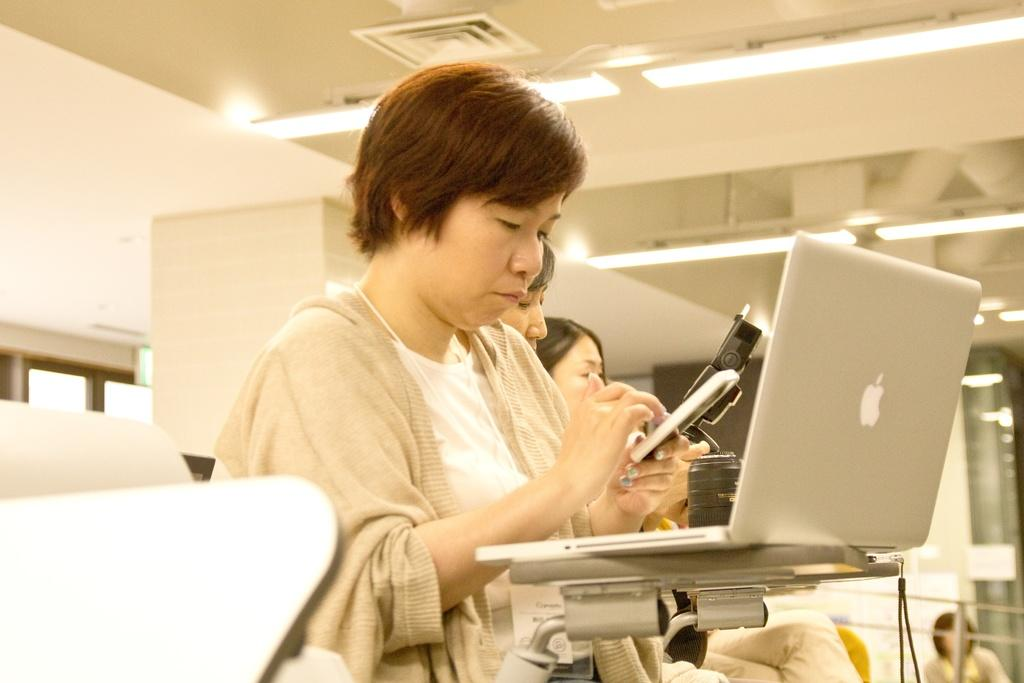What are the people in the image doing? The people in the image are sitting. What electronic device can be seen in the image? There is a laptop in the image. What type of furniture is present in the image? There are chairs in the image. What type of structure is visible in the image? There is a wall in the image. What is on top of the structure in the image? There is a roof with lights in the image. What type of animal can be seen pushing the laptop in the image? There are no animals present in the image, and the laptop is not being pushed. 